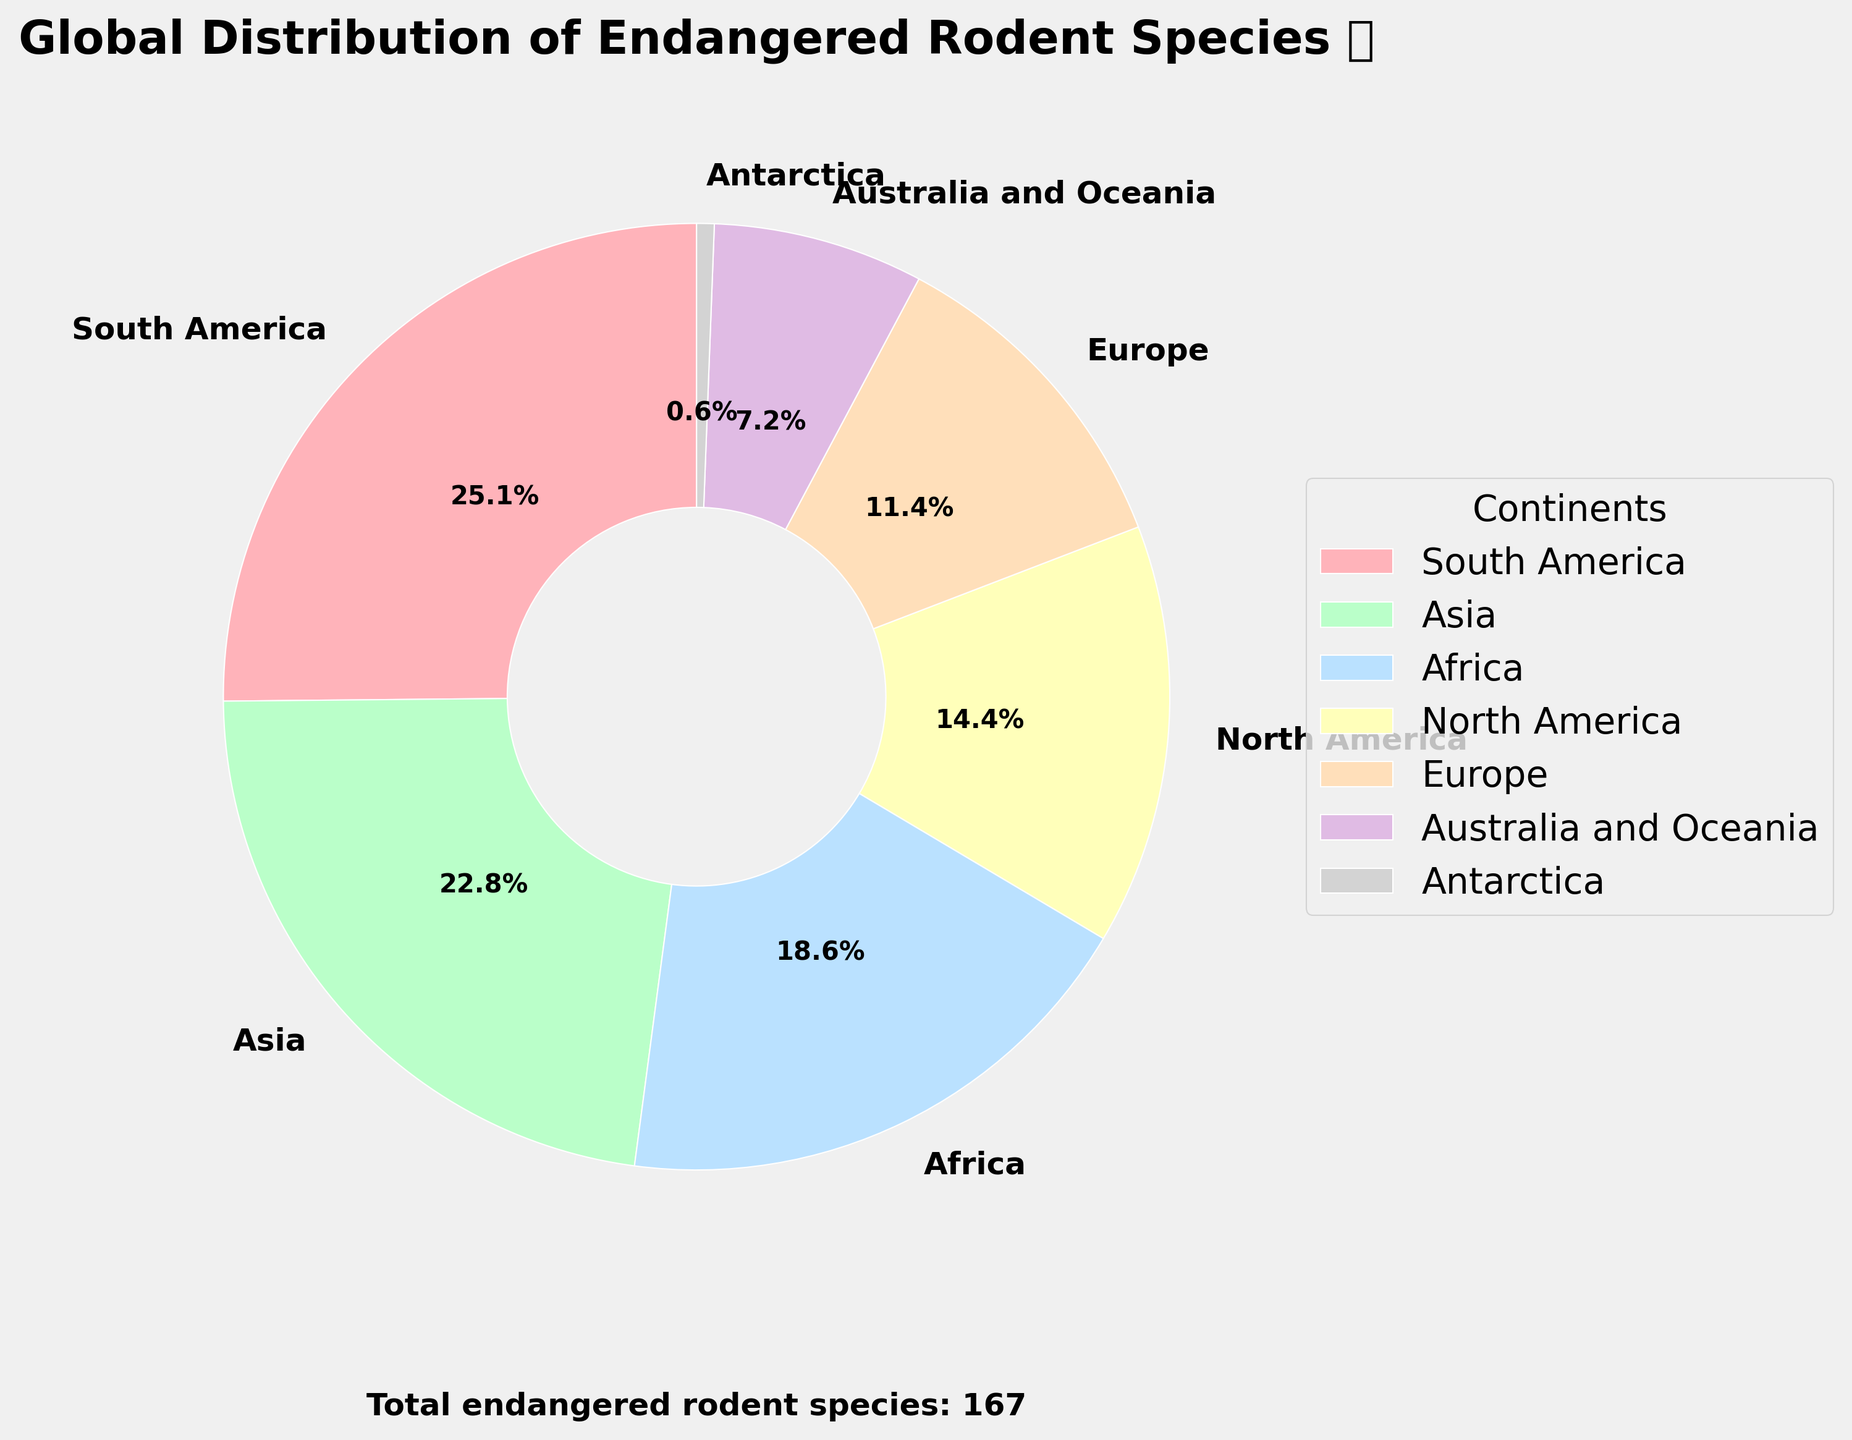Which continent has the highest number of endangered rodent species? The pie chart shows that South America has the largest section among all, indicating it has the highest number of endangered rodent species.
Answer: South America How many endangered rodent species are in North America and Europe combined? According to the pie chart, North America has 24 endangered rodent species and Europe has 19. Adding these numbers gives 24 + 19 = 43.
Answer: 43 Which continent has fewer endangered rodent species than Australia and Oceania? The pie chart shows that Antarctica has the smallest section, indicating fewer endangered rodent species than any other continent.
Answer: Antarctica What percentage of the total endangered rodent species does Asia represent? The pie chart labels Asia as having 38 endangered rodent species, and the info text indicates a total of 167 species. So, the percentage is (38 / 167) * 100 ≈ 22.8%.
Answer: 22.8% Are there more endangered rodent species in Africa or Europe? The pie chart shows that Africa has a larger section than Europe. Africa has 31 species, while Europe has 19 species.
Answer: Africa How many more endangered rodent species are there in South America compared to Australia and Oceania? South America has 42 species, and Australia and Oceania have 12 species. The difference is 42 - 12 = 30.
Answer: 30 Which continent makes up approximately 7.2% of the total endangered rodent species? According to the pie chart, Antarctica has 1 species out of a total of 167. Calculating the percentage: (1 / 167) * 100 ≈ 0.6%. This doesn't match 7.2%, so the corresponding continent would be incorrect.
Answer: None If two more endangered rodent species were discovered in Europe, which continent would have the next closest number of species? If Europe had 21 species (19 + 2), it would be closest to Oceania which has 12 species. The difference would be 21 - 12 = 9, while the next closest difference with North America (24 species) is 24 - 21 = 3.
Answer: North America What is the combined percentage of endangered rodent species in Africa and Australia and Oceania? The pie chart shows that Africa has (31 / 167) * 100 ≈ 18.6%, and Australia and Oceania have (12 / 167) * 100 ≈ 7.2%. Adding these percentages gives 18.6 + 7.2 ≈ 25.8%.
Answer: 25.8% Which continent has the third highest number of endangered rodent species, and how many does it have? The pie chart shows that Africa has the third largest section. Africa has 31 species.
Answer: Africa, 31 